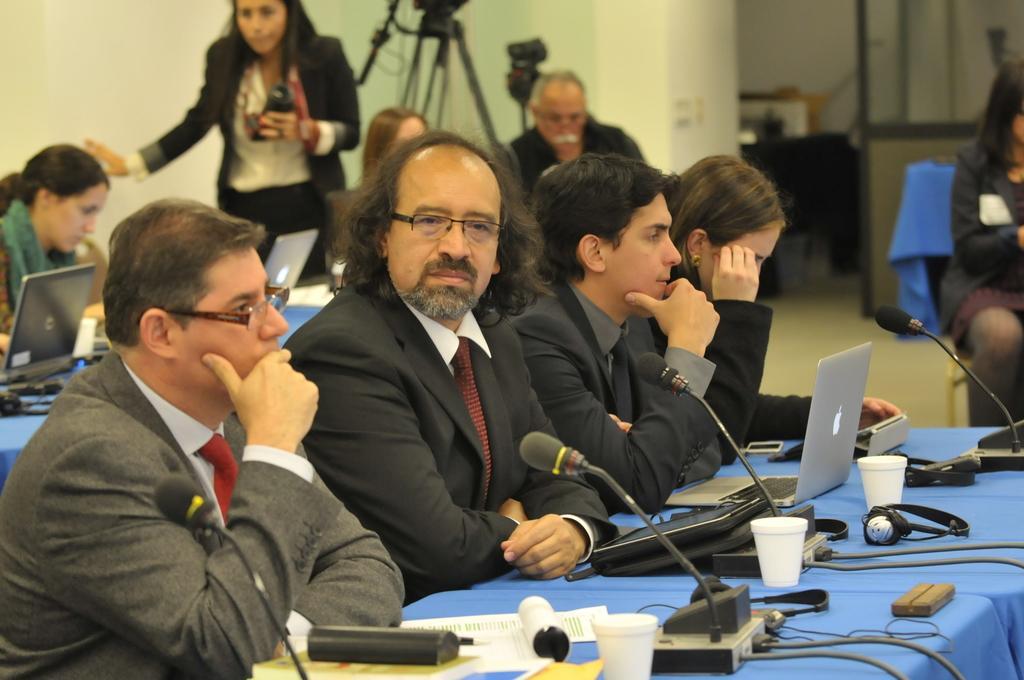Please provide a concise description of this image. In this image we can see some persons, microphones, laptops and other objects. In the background of the image there are persons, wall and other objects. 